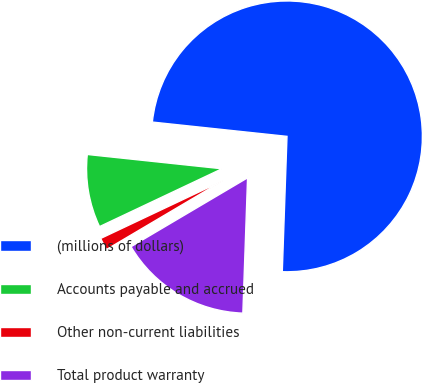<chart> <loc_0><loc_0><loc_500><loc_500><pie_chart><fcel>(millions of dollars)<fcel>Accounts payable and accrued<fcel>Other non-current liabilities<fcel>Total product warranty<nl><fcel>73.87%<fcel>8.71%<fcel>1.47%<fcel>15.95%<nl></chart> 